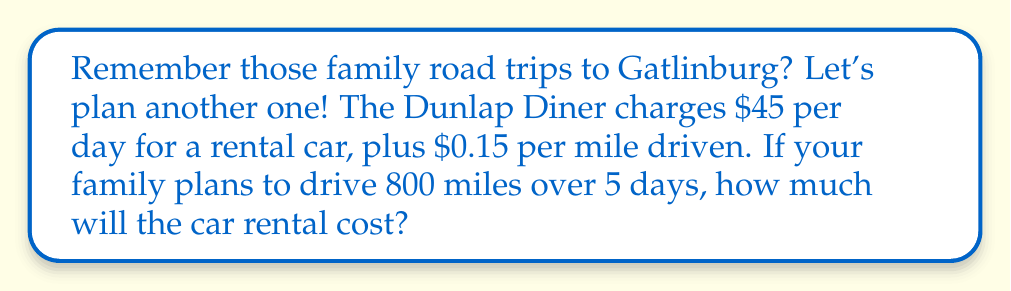Help me with this question. Let's approach this step-by-step using a linear equation:

1) Define our variables:
   $x$ = number of days
   $y$ = total cost in dollars

2) Set up the linear equation:
   $y = 45x + 0.15m$, where $m$ is the number of miles driven

3) We know:
   $x = 5$ days
   $m = 800$ miles

4) Plug these values into our equation:
   $y = 45(5) + 0.15(800)$

5) Solve:
   $y = 225 + 120$
   $y = 345$

Therefore, the total cost for the car rental will be $345.
Answer: $345 